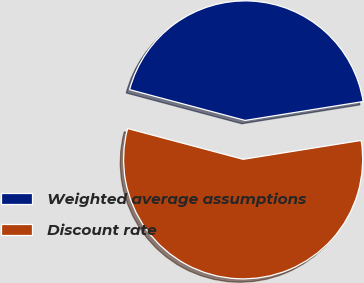<chart> <loc_0><loc_0><loc_500><loc_500><pie_chart><fcel>Weighted average assumptions<fcel>Discount rate<nl><fcel>43.33%<fcel>56.67%<nl></chart> 